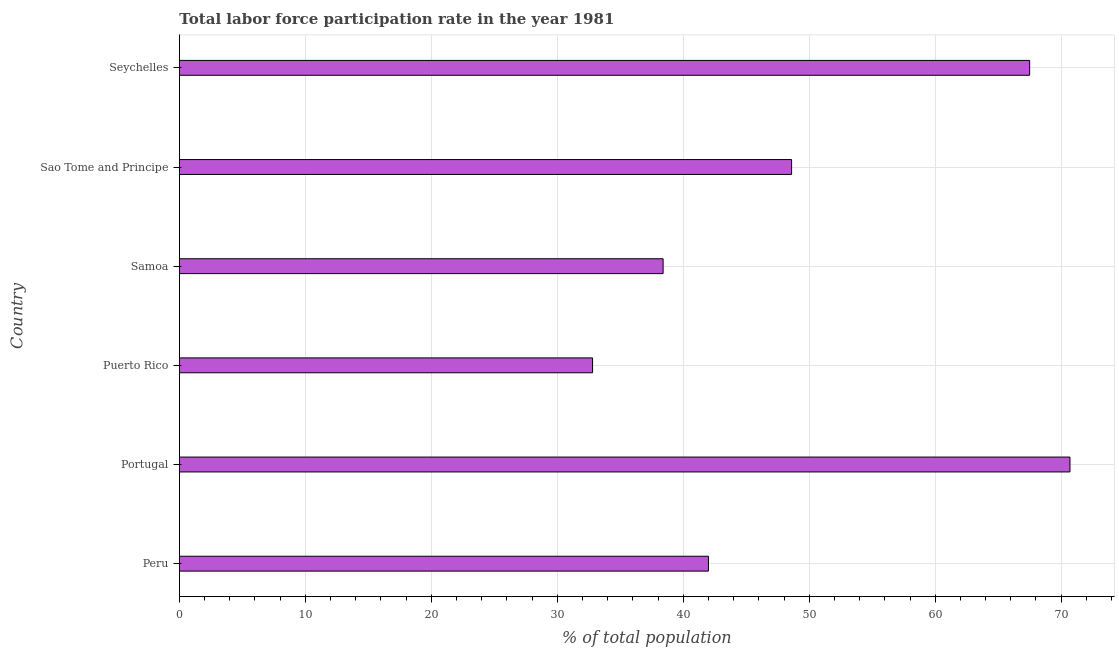Does the graph contain grids?
Make the answer very short. Yes. What is the title of the graph?
Offer a terse response. Total labor force participation rate in the year 1981. What is the label or title of the X-axis?
Offer a terse response. % of total population. What is the total labor force participation rate in Sao Tome and Principe?
Provide a short and direct response. 48.6. Across all countries, what is the maximum total labor force participation rate?
Your answer should be very brief. 70.7. Across all countries, what is the minimum total labor force participation rate?
Make the answer very short. 32.8. In which country was the total labor force participation rate maximum?
Offer a very short reply. Portugal. In which country was the total labor force participation rate minimum?
Keep it short and to the point. Puerto Rico. What is the sum of the total labor force participation rate?
Your answer should be compact. 300. What is the difference between the total labor force participation rate in Samoa and Seychelles?
Your response must be concise. -29.1. What is the average total labor force participation rate per country?
Offer a very short reply. 50. What is the median total labor force participation rate?
Ensure brevity in your answer.  45.3. In how many countries, is the total labor force participation rate greater than 30 %?
Make the answer very short. 6. What is the ratio of the total labor force participation rate in Portugal to that in Sao Tome and Principe?
Give a very brief answer. 1.46. Is the difference between the total labor force participation rate in Puerto Rico and Sao Tome and Principe greater than the difference between any two countries?
Ensure brevity in your answer.  No. What is the difference between the highest and the second highest total labor force participation rate?
Your answer should be very brief. 3.2. What is the difference between the highest and the lowest total labor force participation rate?
Keep it short and to the point. 37.9. How many countries are there in the graph?
Offer a terse response. 6. What is the difference between two consecutive major ticks on the X-axis?
Your answer should be very brief. 10. Are the values on the major ticks of X-axis written in scientific E-notation?
Keep it short and to the point. No. What is the % of total population of Portugal?
Provide a succinct answer. 70.7. What is the % of total population of Puerto Rico?
Ensure brevity in your answer.  32.8. What is the % of total population of Samoa?
Keep it short and to the point. 38.4. What is the % of total population in Sao Tome and Principe?
Offer a very short reply. 48.6. What is the % of total population of Seychelles?
Ensure brevity in your answer.  67.5. What is the difference between the % of total population in Peru and Portugal?
Provide a short and direct response. -28.7. What is the difference between the % of total population in Peru and Puerto Rico?
Your response must be concise. 9.2. What is the difference between the % of total population in Peru and Samoa?
Make the answer very short. 3.6. What is the difference between the % of total population in Peru and Seychelles?
Offer a terse response. -25.5. What is the difference between the % of total population in Portugal and Puerto Rico?
Provide a succinct answer. 37.9. What is the difference between the % of total population in Portugal and Samoa?
Your response must be concise. 32.3. What is the difference between the % of total population in Portugal and Sao Tome and Principe?
Keep it short and to the point. 22.1. What is the difference between the % of total population in Portugal and Seychelles?
Your response must be concise. 3.2. What is the difference between the % of total population in Puerto Rico and Sao Tome and Principe?
Your answer should be very brief. -15.8. What is the difference between the % of total population in Puerto Rico and Seychelles?
Provide a short and direct response. -34.7. What is the difference between the % of total population in Samoa and Sao Tome and Principe?
Make the answer very short. -10.2. What is the difference between the % of total population in Samoa and Seychelles?
Provide a succinct answer. -29.1. What is the difference between the % of total population in Sao Tome and Principe and Seychelles?
Your answer should be compact. -18.9. What is the ratio of the % of total population in Peru to that in Portugal?
Make the answer very short. 0.59. What is the ratio of the % of total population in Peru to that in Puerto Rico?
Offer a very short reply. 1.28. What is the ratio of the % of total population in Peru to that in Samoa?
Your answer should be very brief. 1.09. What is the ratio of the % of total population in Peru to that in Sao Tome and Principe?
Give a very brief answer. 0.86. What is the ratio of the % of total population in Peru to that in Seychelles?
Your answer should be very brief. 0.62. What is the ratio of the % of total population in Portugal to that in Puerto Rico?
Offer a terse response. 2.15. What is the ratio of the % of total population in Portugal to that in Samoa?
Offer a very short reply. 1.84. What is the ratio of the % of total population in Portugal to that in Sao Tome and Principe?
Your response must be concise. 1.46. What is the ratio of the % of total population in Portugal to that in Seychelles?
Make the answer very short. 1.05. What is the ratio of the % of total population in Puerto Rico to that in Samoa?
Make the answer very short. 0.85. What is the ratio of the % of total population in Puerto Rico to that in Sao Tome and Principe?
Provide a succinct answer. 0.68. What is the ratio of the % of total population in Puerto Rico to that in Seychelles?
Your response must be concise. 0.49. What is the ratio of the % of total population in Samoa to that in Sao Tome and Principe?
Keep it short and to the point. 0.79. What is the ratio of the % of total population in Samoa to that in Seychelles?
Make the answer very short. 0.57. What is the ratio of the % of total population in Sao Tome and Principe to that in Seychelles?
Give a very brief answer. 0.72. 